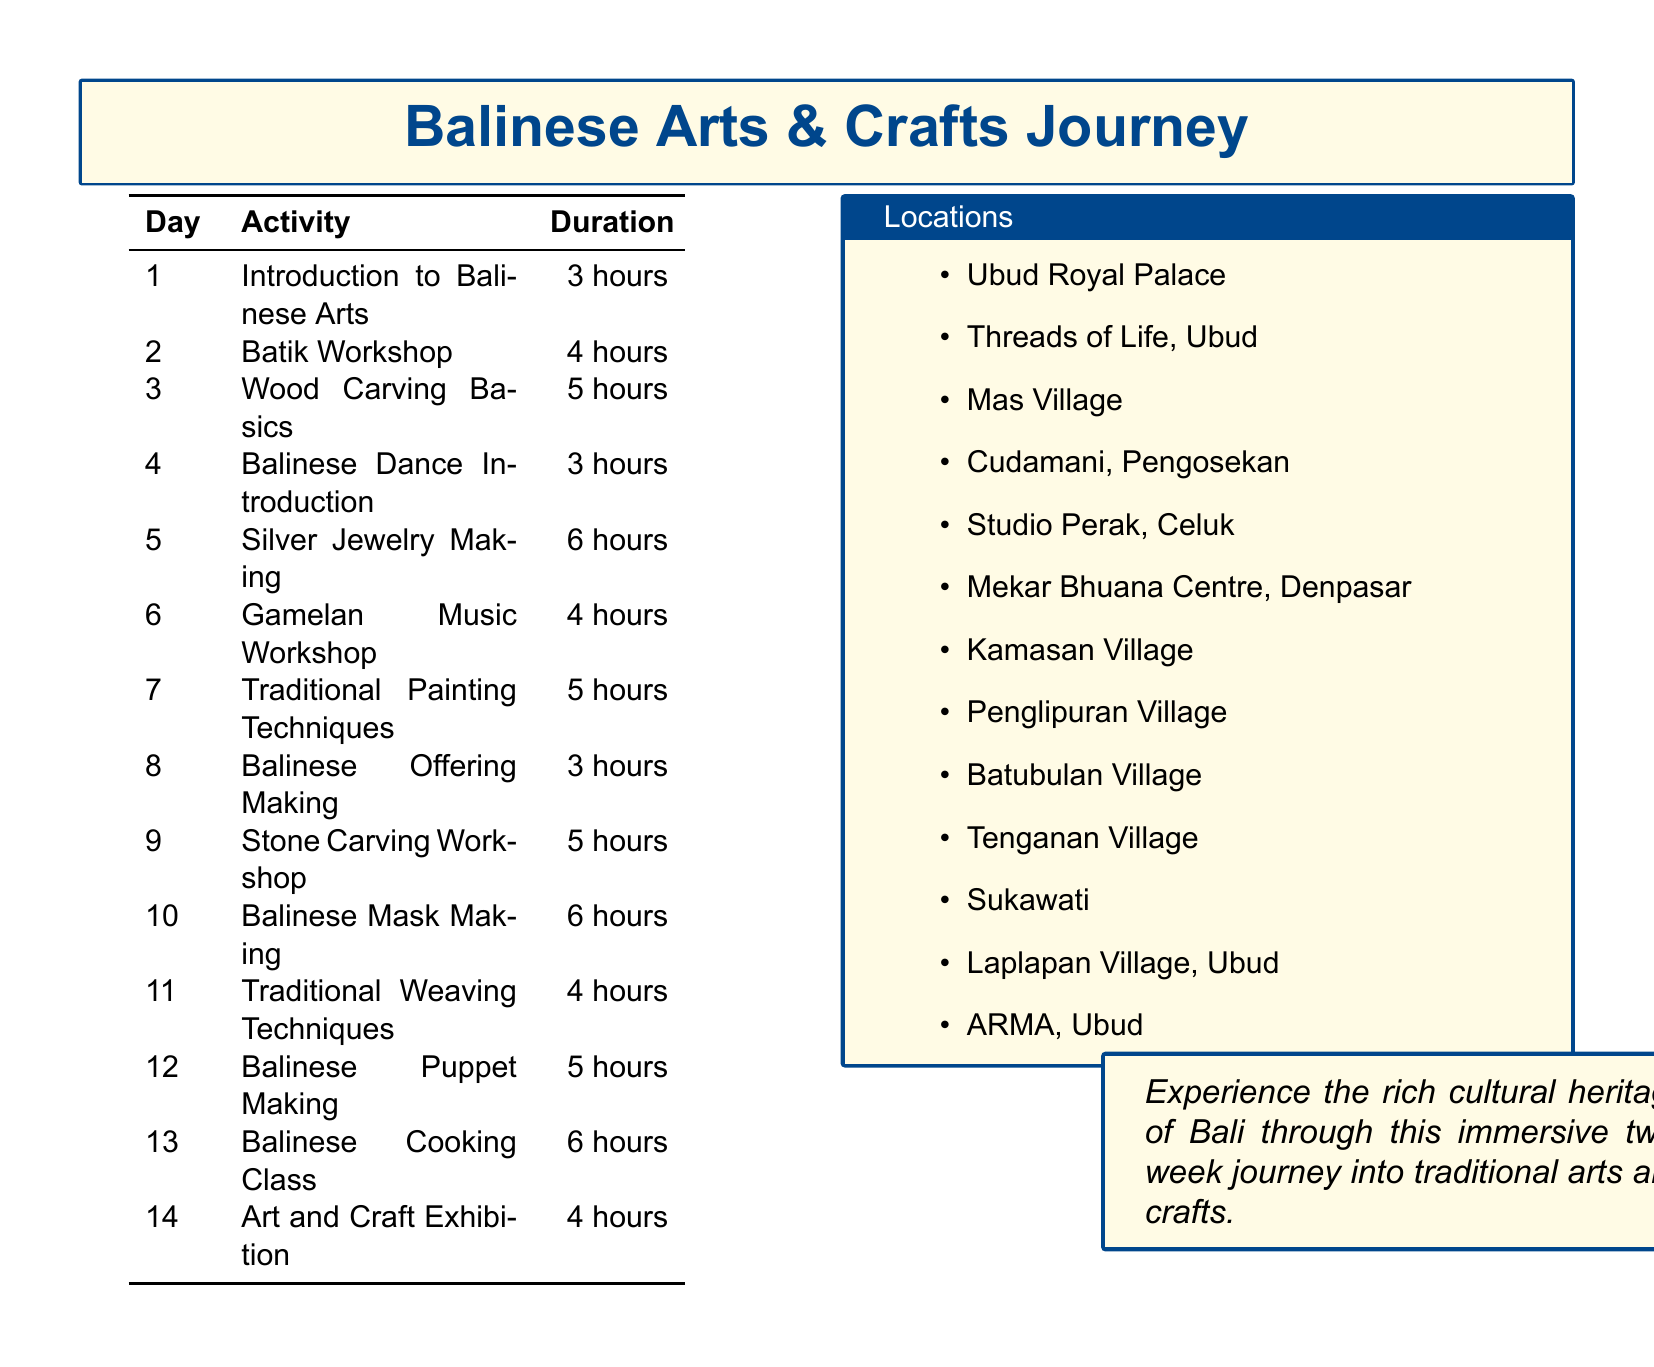What is the duration of the Batik Workshop? The duration of the Batik Workshop is specified in the document.
Answer: 4 hours Where is the Balinese Cooking Class held? The document lists the location of the Balinese Cooking Class.
Answer: Laplapan Village, Ubud On which day is the Art and Craft Exhibition scheduled? The day of the Art and Craft Exhibition is mentioned in the agenda items.
Answer: Day 14 How many hours are allocated for the Silver Jewelry Making activity? The document indicates the hours for the Silver Jewelry Making activity.
Answer: 6 hours Which traditional art involves creating masks? The document specifically mentions the craft related to making masks.
Answer: Balinese Mask Making What is the location for learning traditional weaving techniques? The agenda provides the location for traditional weaving techniques.
Answer: Tenganan Village How many activities are scheduled for the first week? The number of activities in the first week can be counted from the agenda.
Answer: 7 activities Who is the master carver for the Wood Carving Basics lesson? The document specifies the name of the master carver for Wood Carving Basics.
Answer: I Wayan Mudana 